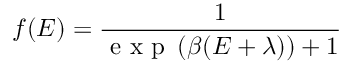<formula> <loc_0><loc_0><loc_500><loc_500>f ( E ) = \frac { 1 } { e x p \left ( \beta ( E + \lambda ) \right ) + 1 }</formula> 